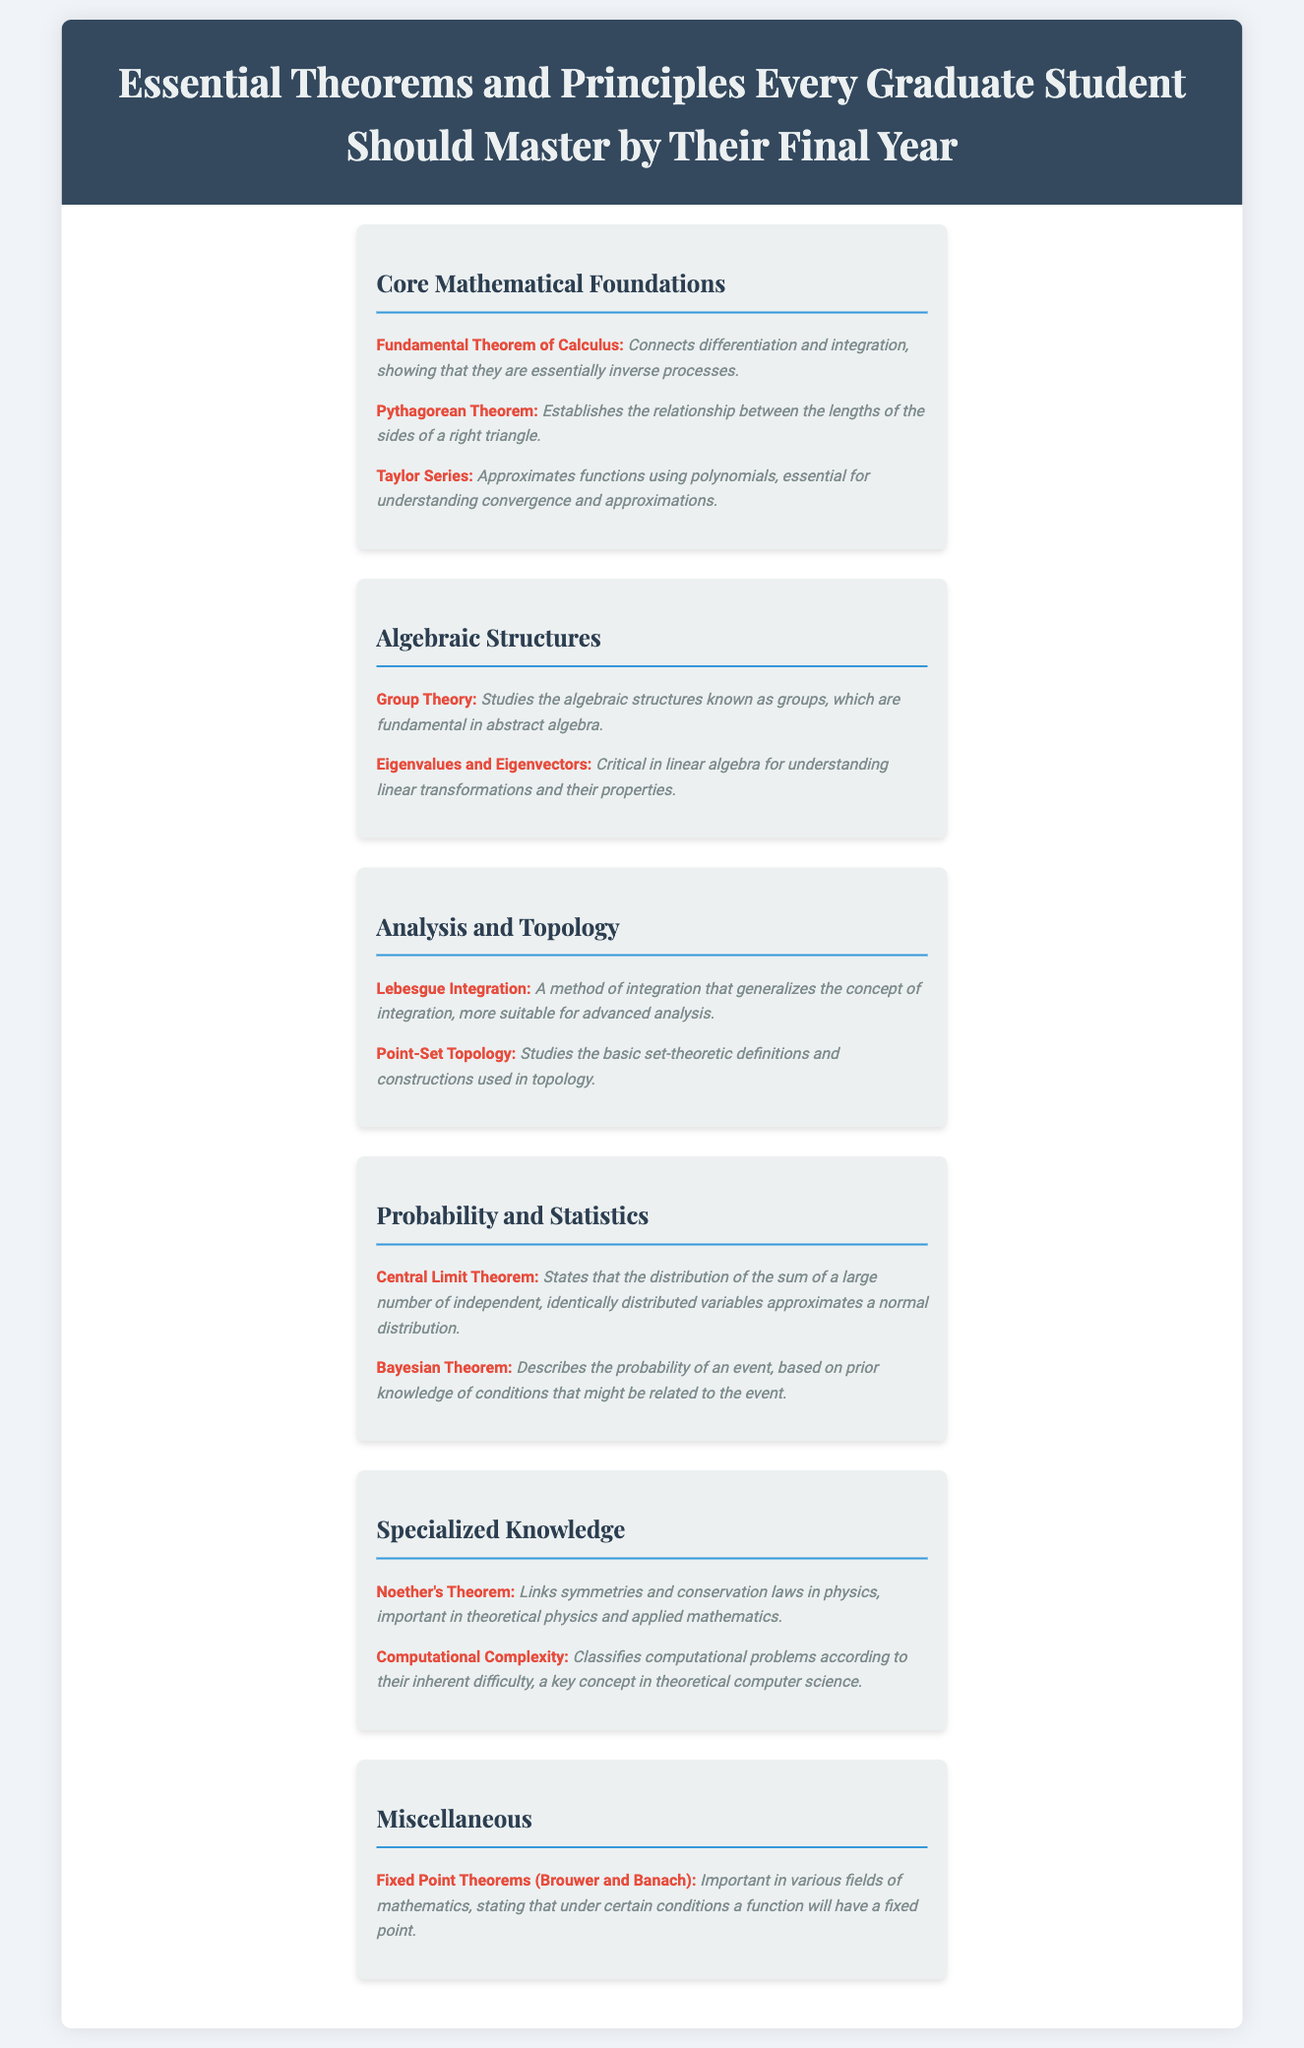What is the title of the document? The title is the main heading of the document, which summarizes its content.
Answer: Essential Theorems and Principles Every Graduate Student Should Master by Their Final Year How many sections are in the document? The document contains multiple sections, each one addressing a different area of mathematical study.
Answer: Six What theorem connects differentiation and integration? This theorem establishes a key relationship between two fundamental concepts in calculus.
Answer: Fundamental Theorem of Calculus Which theorem states that a function will have a fixed point under certain conditions? This theorem is mentioned under the Miscellaneous section and is important in various fields of mathematics.
Answer: Fixed Point Theorems (Brouwer and Banach) What area does Noether's Theorem relate to? The theorem is critical in a specific field that examines conservation laws and their symmetries.
Answer: Theoretical physics What is the primary focus of Group Theory? This area of study concentrates on a specific algebraic structure that is essential in a mathematical discipline.
Answer: Groups 